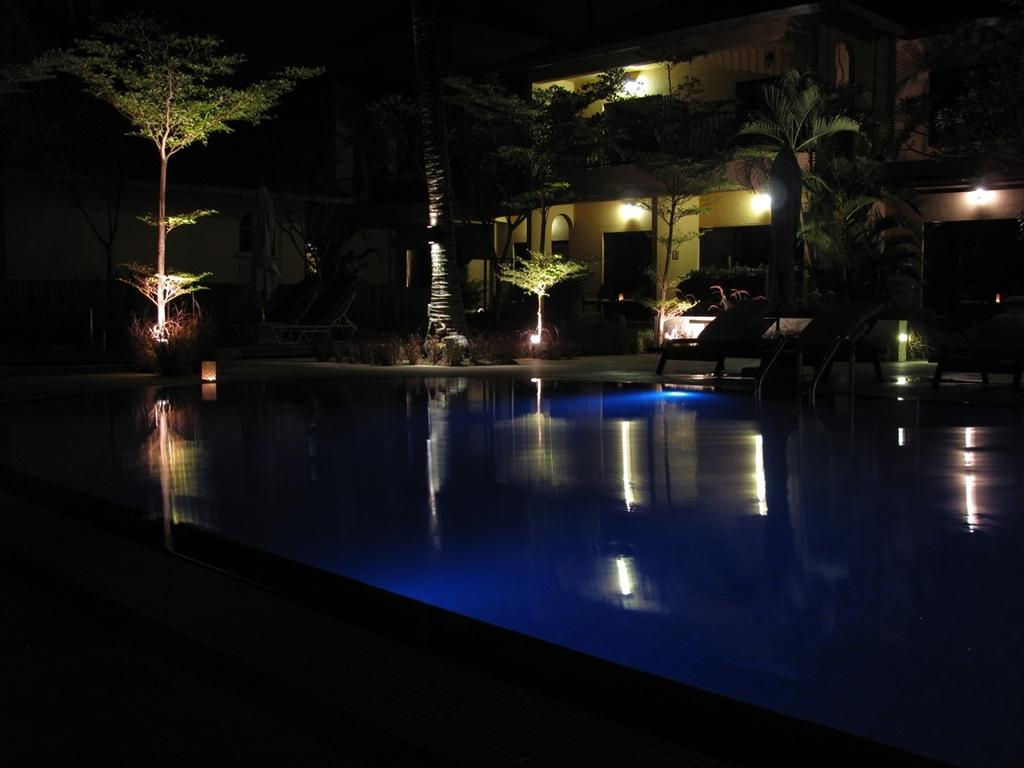What is the main feature in the front of the image? There is a pool in the front of the image. What structure is located behind the pool? There is a building behind the pool. What type of vegetation is present in front of the building? Trees are present in front of the building. Can you describe the lighting inside the building? There are lights inside the building. What time of day is it in the image, given the presence of quince? There is no mention of quince in the image, so we cannot determine the time of day based on that. 